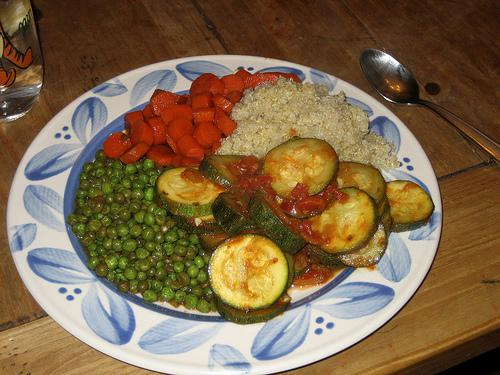Question: what is the table made of?
Choices:
A. Plastic.
B. Marble.
C. Aluminium.
D. Wood.
Answer with the letter. Answer: D Question: where is the spoon?
Choices:
A. In the drawer.
B. On the table.
C. Next to the plate.
D. In the bowl.
Answer with the letter. Answer: B Question: how many plates are on the table?
Choices:
A. 2.
B. 4.
C. 1.
D. 5.
Answer with the letter. Answer: C Question: what color is the plate?
Choices:
A. White.
B. Blue and white.
C. Yellow.
D. Red.
Answer with the letter. Answer: B Question: what color is the spoon?
Choices:
A. Silver.
B. Gold.
C. Blue.
D. Black.
Answer with the letter. Answer: A Question: how many utensils are there?
Choices:
A. 2.
B. 4.
C. 5.
D. 1.
Answer with the letter. Answer: D 